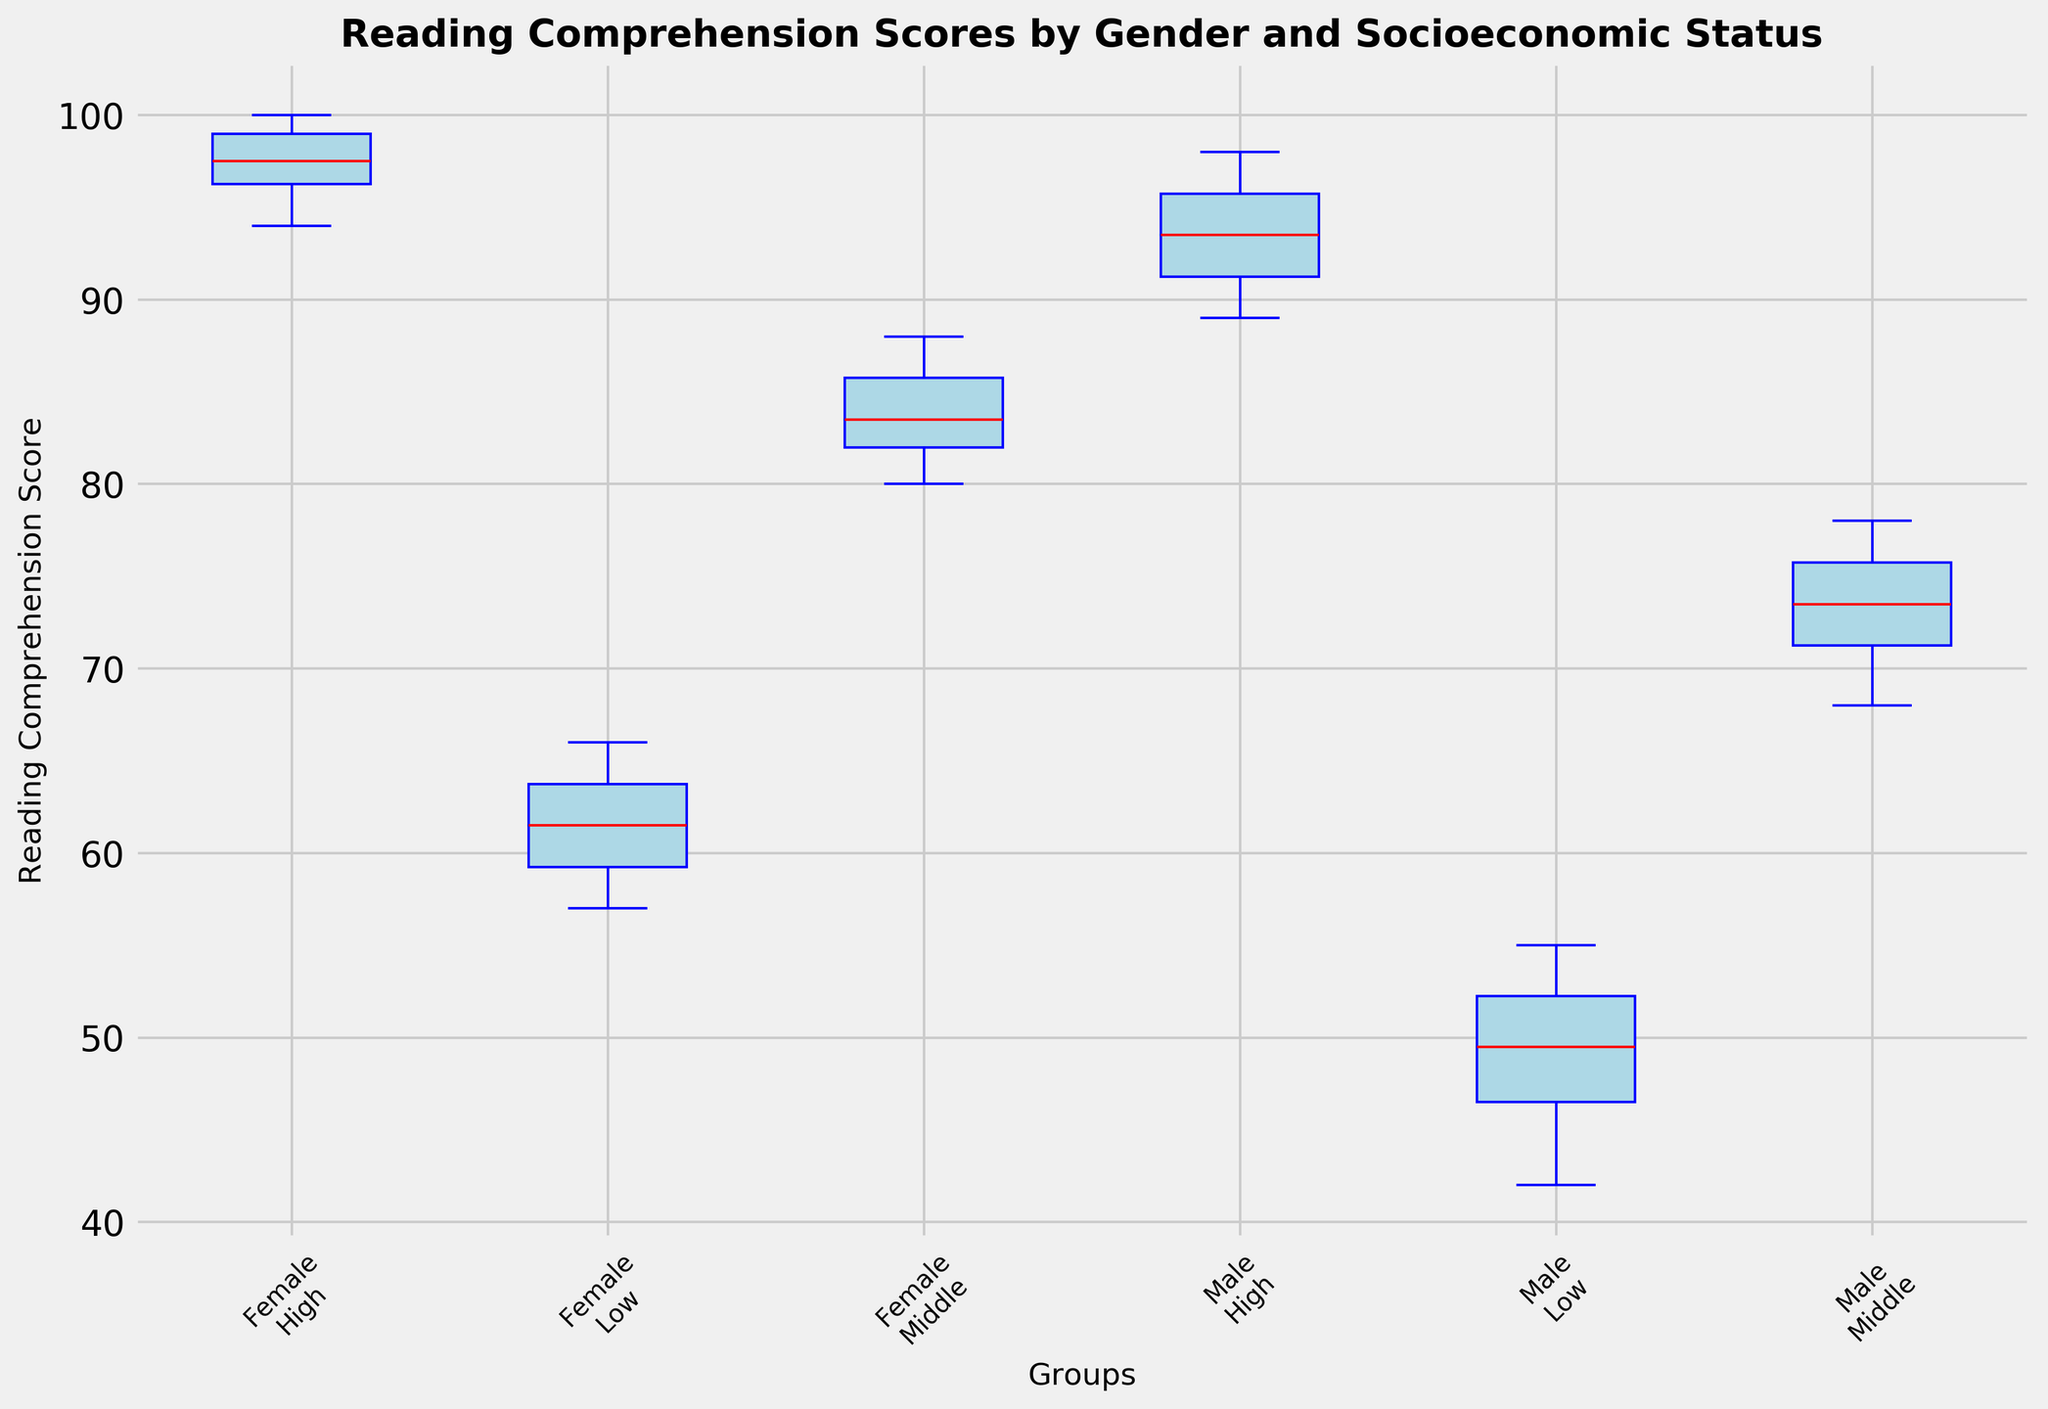What's the median reading comprehension score for female students from low socioeconomic status? The box plot's median is typically indicated by a line inside the box. Find the box corresponding to female students with low socioeconomic status and locate the red line inside it.
Answer: 61 Which group has the highest median reading comprehension score? Compare the medians (red lines) of all the groups. The highest median score is represented by the tallest line.
Answer: Female, High What is the range of scores for male students with high socioeconomic status? Range is calculated by subtracting the lowest value (bottom whisker) from the highest value (top whisker). Locate the male high-socioeconomic-status box, identify the position of these whiskers, then subtract.
Answer: 98 - 89 = 9 Who has a greater variability in reading comprehension scores, male or female students from middle socioeconomic status? Variability can be observed by looking at the length of the boxes and whiskers. Compare the middle socioeconomic boxes for both genders.
Answer: Male students Compare the median reading comprehension scores between male and female students from low socioeconomic status. Check the red lines inside the boxes for both genders with low socioeconomic status.
Answer: Female students have a higher median Which group has the widest interquartile range (IQR) for reading comprehension scores? IQR is shown by the height of the box. Identify the box with the greatest height among all groups.
Answer: Female, Low Are there any outliers shown in the box plot? Outliers in a box plot are observed as individual points outside the whiskers. Check if there are any isolated points in the plot.
Answer: No outliers How does the median score for male students from middle socioeconomic status compare to the median score of male students from low socioeconomic status? Compare the red lines for male students from middle and low socioeconomic statuses.
Answer: Higher in middle What is the median reading comprehension score for male students from high socioeconomic status? Find the red line in the box corresponding to male students with high socioeconomic status.
Answer: 94 